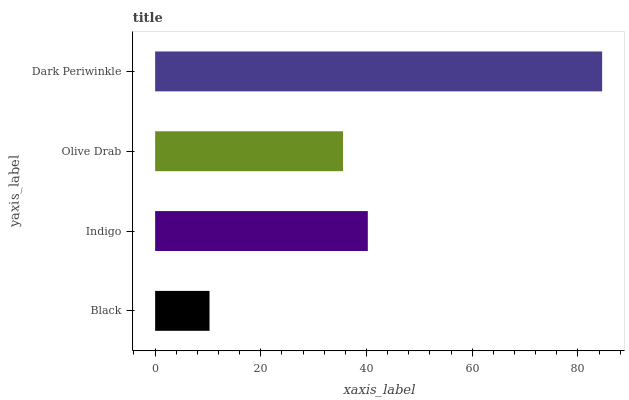Is Black the minimum?
Answer yes or no. Yes. Is Dark Periwinkle the maximum?
Answer yes or no. Yes. Is Indigo the minimum?
Answer yes or no. No. Is Indigo the maximum?
Answer yes or no. No. Is Indigo greater than Black?
Answer yes or no. Yes. Is Black less than Indigo?
Answer yes or no. Yes. Is Black greater than Indigo?
Answer yes or no. No. Is Indigo less than Black?
Answer yes or no. No. Is Indigo the high median?
Answer yes or no. Yes. Is Olive Drab the low median?
Answer yes or no. Yes. Is Dark Periwinkle the high median?
Answer yes or no. No. Is Black the low median?
Answer yes or no. No. 